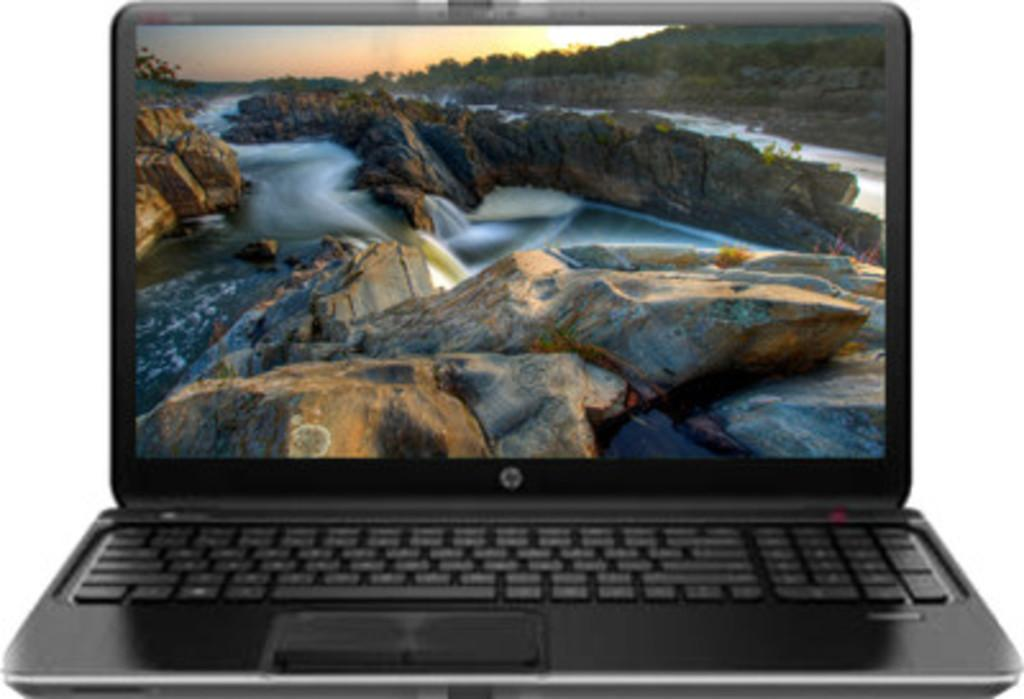What type of electronic device is visible in the image? There is a black color laptop in the image. What is displayed on the laptop screen? The laptop screen displays rocks and water. What color is the background in the image? There is a white color background in the image. What type of crime is being committed in the image? There is no crime being committed in the image; it features a laptop displaying rocks and water. How many books are visible in the image? There are no books visible in the image; it features a laptop and a white background. 